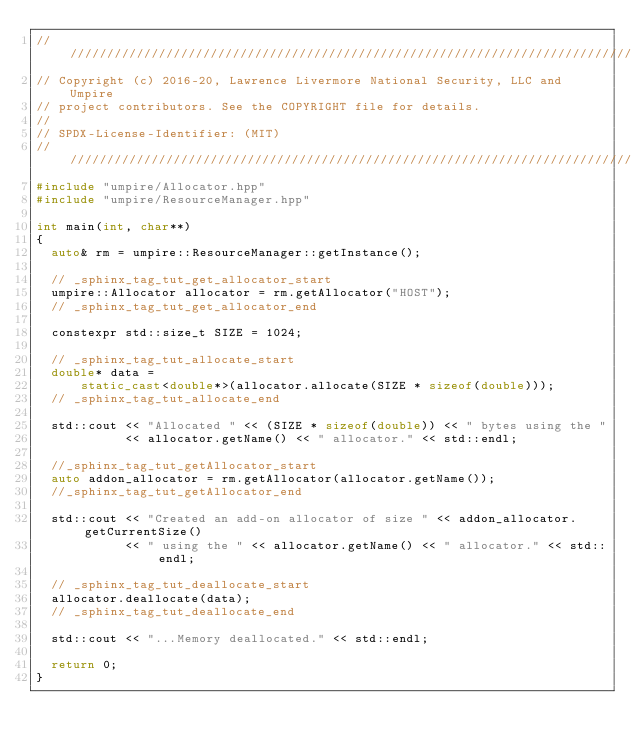<code> <loc_0><loc_0><loc_500><loc_500><_C++_>//////////////////////////////////////////////////////////////////////////////
// Copyright (c) 2016-20, Lawrence Livermore National Security, LLC and Umpire
// project contributors. See the COPYRIGHT file for details.
//
// SPDX-License-Identifier: (MIT)
//////////////////////////////////////////////////////////////////////////////
#include "umpire/Allocator.hpp"
#include "umpire/ResourceManager.hpp"

int main(int, char**)
{
  auto& rm = umpire::ResourceManager::getInstance();

  // _sphinx_tag_tut_get_allocator_start
  umpire::Allocator allocator = rm.getAllocator("HOST");
  // _sphinx_tag_tut_get_allocator_end

  constexpr std::size_t SIZE = 1024;

  // _sphinx_tag_tut_allocate_start
  double* data =
      static_cast<double*>(allocator.allocate(SIZE * sizeof(double)));
  // _sphinx_tag_tut_allocate_end

  std::cout << "Allocated " << (SIZE * sizeof(double)) << " bytes using the "
            << allocator.getName() << " allocator." << std::endl;

  //_sphinx_tag_tut_getAllocator_start
  auto addon_allocator = rm.getAllocator(allocator.getName());
  //_sphinx_tag_tut_getAllocator_end
  
  std::cout << "Created an add-on allocator of size " << addon_allocator.getCurrentSize()
            << " using the " << allocator.getName() << " allocator." << std::endl;

  // _sphinx_tag_tut_deallocate_start
  allocator.deallocate(data);
  // _sphinx_tag_tut_deallocate_end

  std::cout << "...Memory deallocated." << std::endl;

  return 0;
}

</code> 